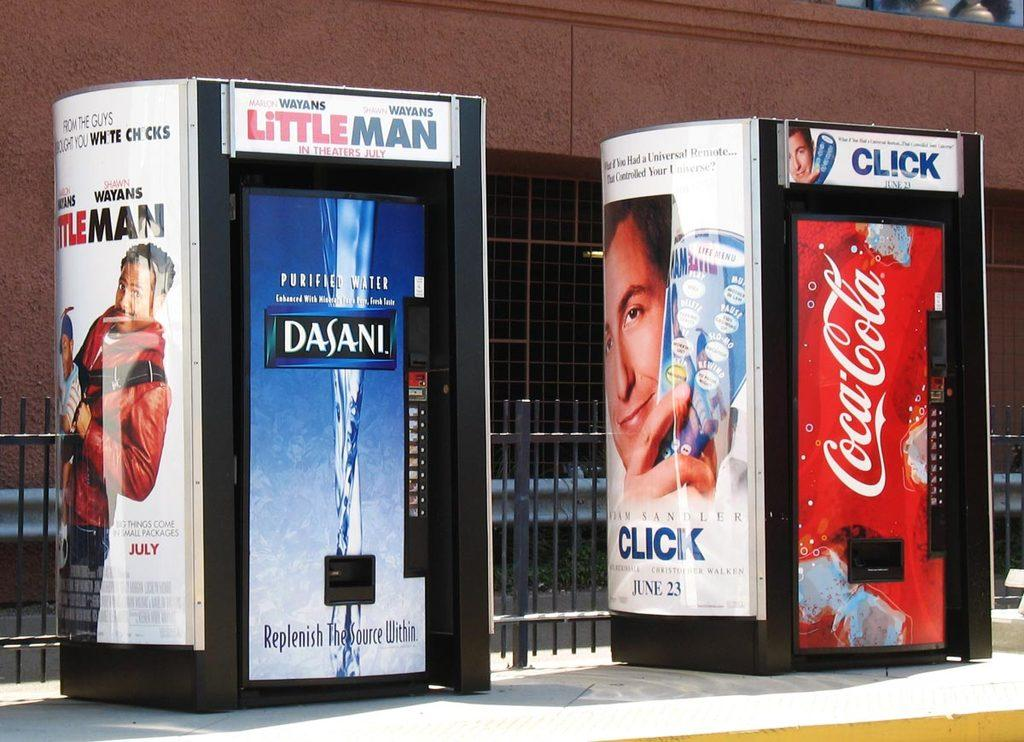How many booths can be seen in the image? There are two booths in the image. What is attached to the booths? Boards are attached to the booths. What type of structure is visible in the image? There is a wall visible in the image. What type of barrier can be seen in the image? There is fencing in the image. What flavor of stitch is used to sew the side of the booths in the image? There is no mention of stitching or flavors in the image, as it features booths with boards and a wall with fencing. 